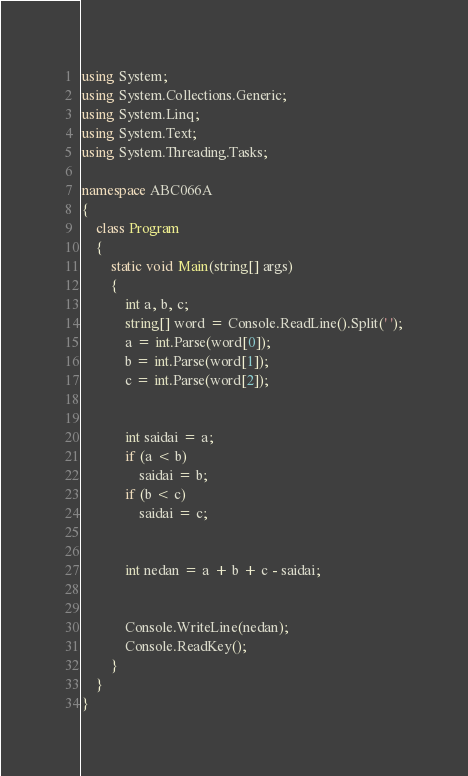<code> <loc_0><loc_0><loc_500><loc_500><_C#_>using System;
using System.Collections.Generic;
using System.Linq;
using System.Text;
using System.Threading.Tasks;

namespace ABC066A
{
    class Program
    {
        static void Main(string[] args)
        {
            int a, b, c;
            string[] word = Console.ReadLine().Split(' ');
            a = int.Parse(word[0]);
            b = int.Parse(word[1]);
            c = int.Parse(word[2]);


            int saidai = a;
            if (a < b)
                saidai = b;
            if (b < c)
                saidai = c;


            int nedan = a + b + c - saidai;


            Console.WriteLine(nedan);
            Console.ReadKey();
        }
    }
}</code> 